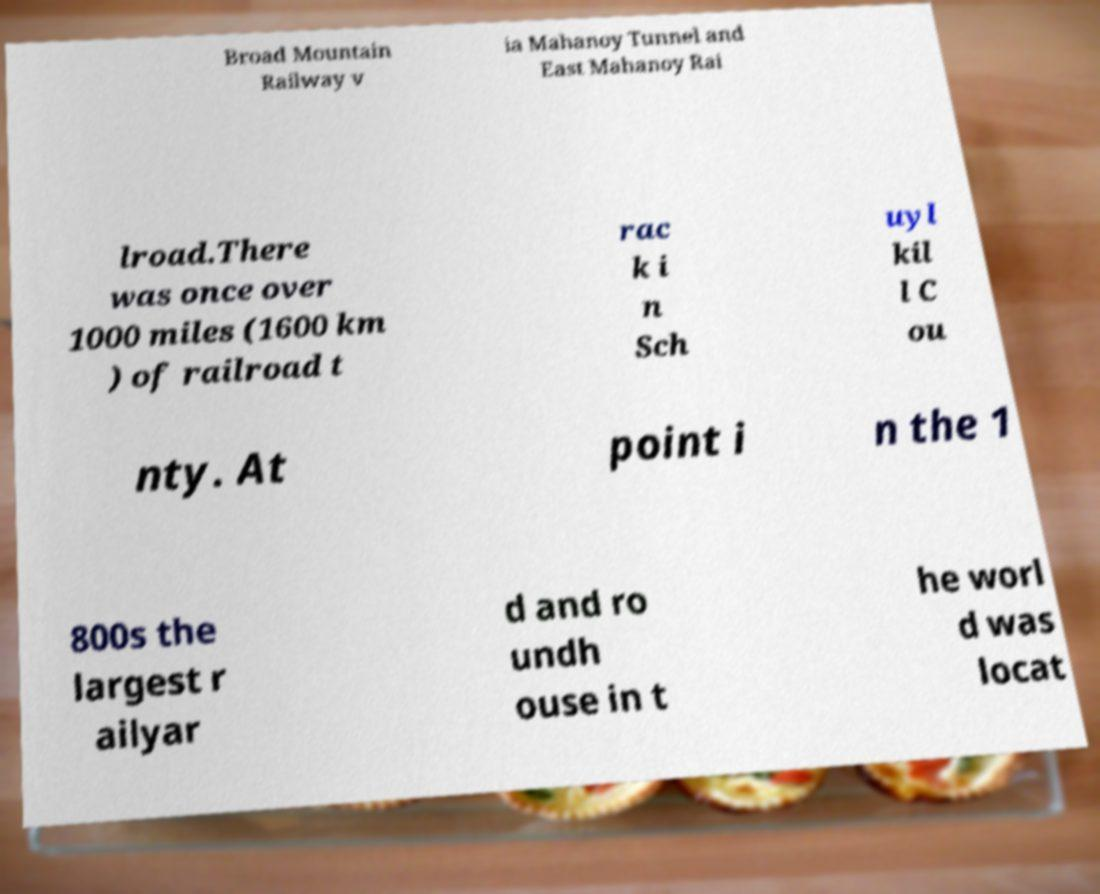Can you read and provide the text displayed in the image?This photo seems to have some interesting text. Can you extract and type it out for me? Broad Mountain Railway v ia Mahanoy Tunnel and East Mahanoy Rai lroad.There was once over 1000 miles (1600 km ) of railroad t rac k i n Sch uyl kil l C ou nty. At point i n the 1 800s the largest r ailyar d and ro undh ouse in t he worl d was locat 